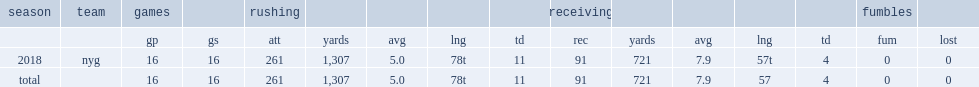How many rushing yards did barkley get in 2018? 1307.0. 